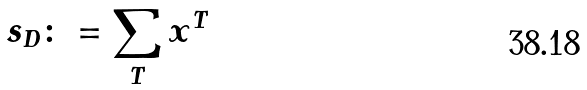Convert formula to latex. <formula><loc_0><loc_0><loc_500><loc_500>s _ { D } \colon = \sum _ { T } x ^ { T }</formula> 